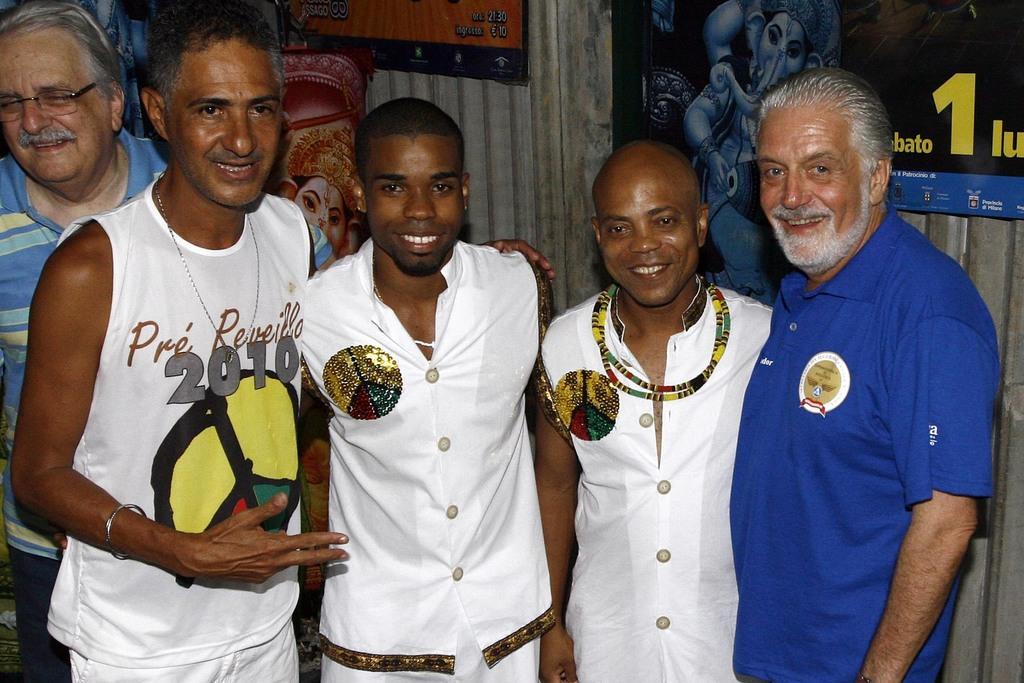Describe this image in one or two sentences. In the foreground of the picture there are people standing. In the center there are three men wearing white dress. In the background there are posters attached to the wall. 